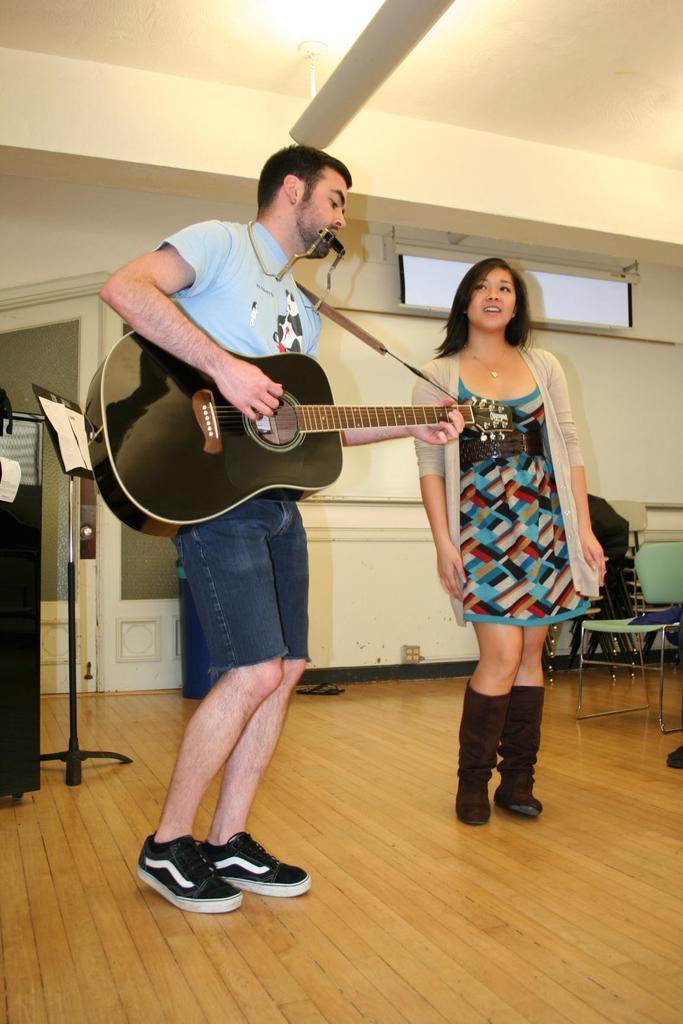Can you describe this image briefly? As we can see in the image there is a white color wall and two people standing over here. The man who is standing here is holding guitar. 